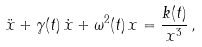<formula> <loc_0><loc_0><loc_500><loc_500>\ddot { x } + \gamma ( t ) \, \dot { x } + \omega ^ { 2 } ( t ) \, x = \frac { k ( t ) } { x ^ { 3 } } \, ,</formula> 